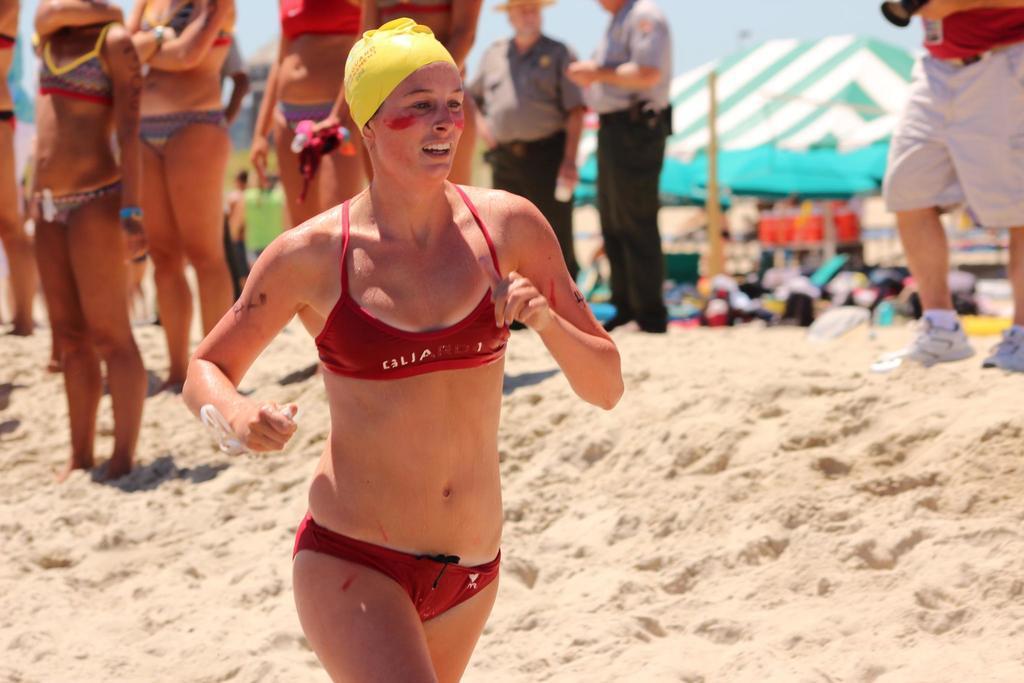Please provide a concise description of this image. In this image there are people standing on sand, in the background there are tents and it is blurred. 